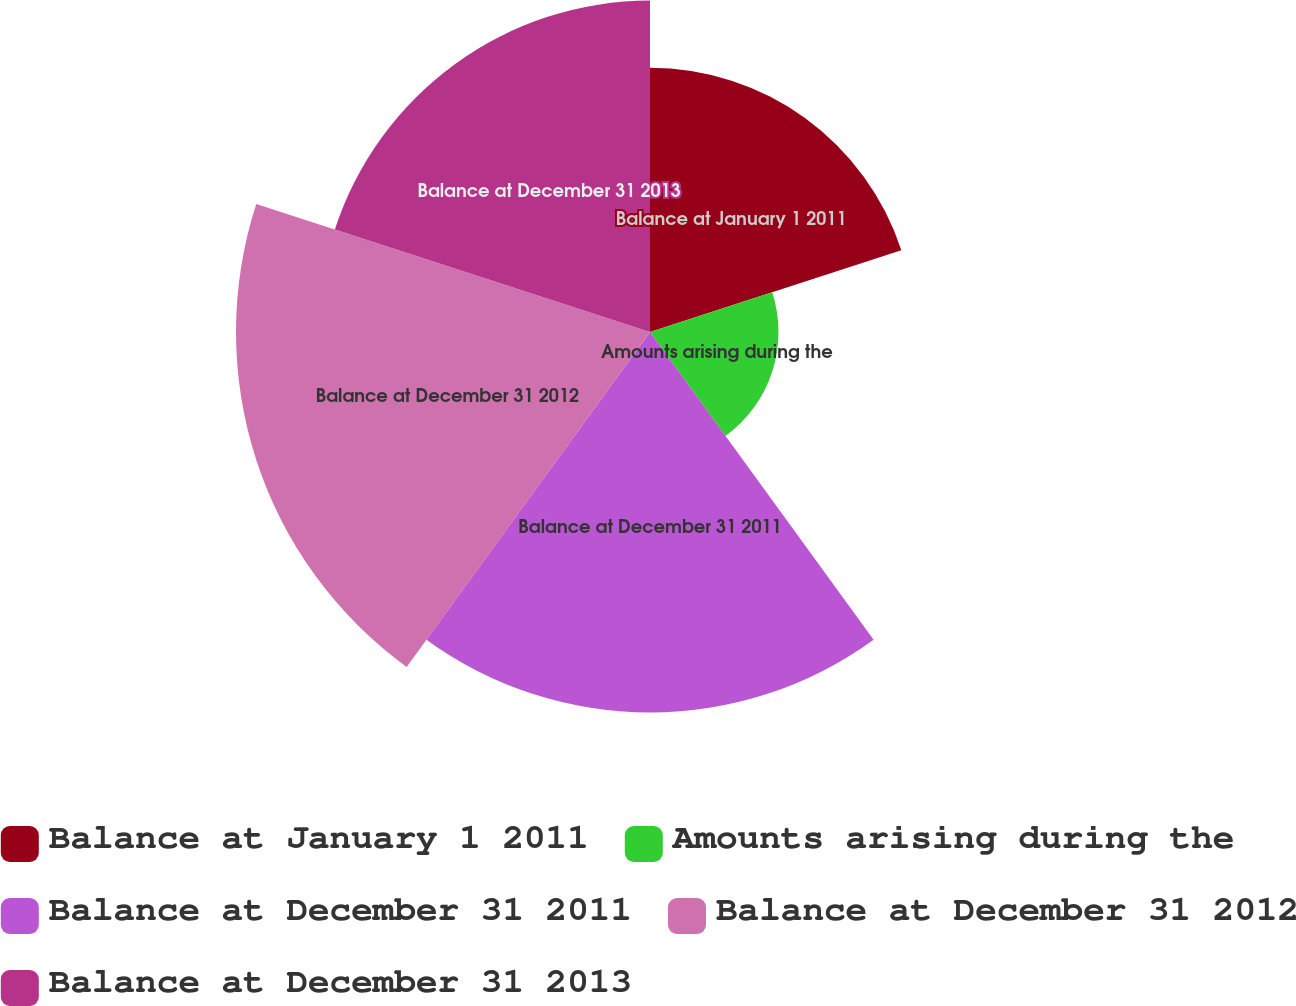<chart> <loc_0><loc_0><loc_500><loc_500><pie_chart><fcel>Balance at January 1 2011<fcel>Amounts arising during the<fcel>Balance at December 31 2011<fcel>Balance at December 31 2012<fcel>Balance at December 31 2013<nl><fcel>17.4%<fcel>8.46%<fcel>25.05%<fcel>27.26%<fcel>21.82%<nl></chart> 